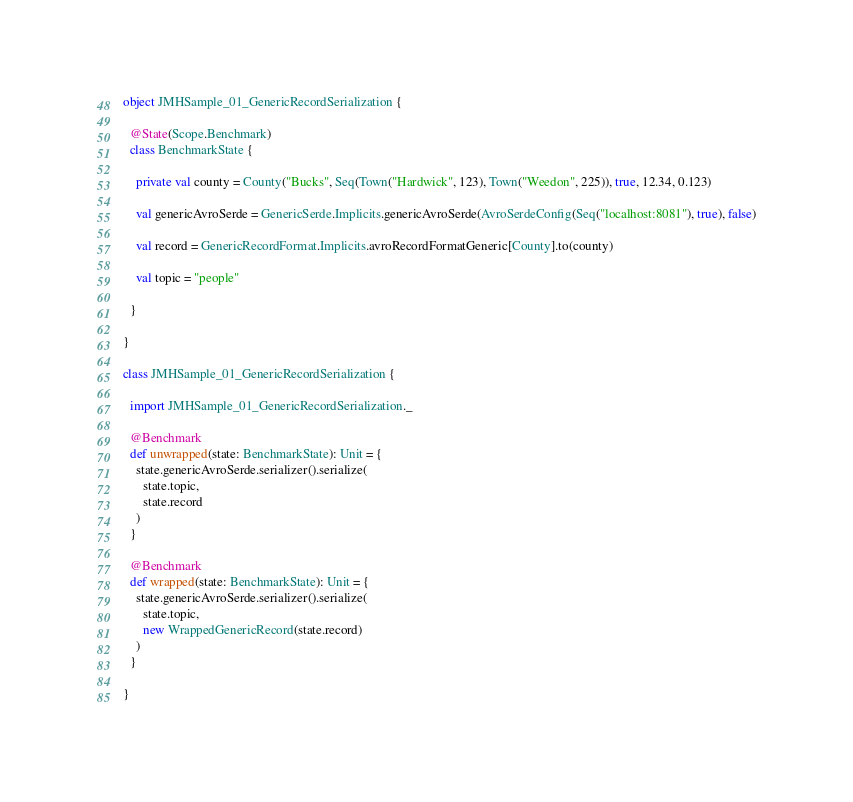Convert code to text. <code><loc_0><loc_0><loc_500><loc_500><_Scala_>object JMHSample_01_GenericRecordSerialization {

  @State(Scope.Benchmark)
  class BenchmarkState {

    private val county = County("Bucks", Seq(Town("Hardwick", 123), Town("Weedon", 225)), true, 12.34, 0.123)

    val genericAvroSerde = GenericSerde.Implicits.genericAvroSerde(AvroSerdeConfig(Seq("localhost:8081"), true), false)

    val record = GenericRecordFormat.Implicits.avroRecordFormatGeneric[County].to(county)

    val topic = "people"

  }

}

class JMHSample_01_GenericRecordSerialization {

  import JMHSample_01_GenericRecordSerialization._

  @Benchmark
  def unwrapped(state: BenchmarkState): Unit = {
    state.genericAvroSerde.serializer().serialize(
      state.topic,
      state.record
    )
  }

  @Benchmark
  def wrapped(state: BenchmarkState): Unit = {
    state.genericAvroSerde.serializer().serialize(
      state.topic,
      new WrappedGenericRecord(state.record)
    )
  }

}
</code> 